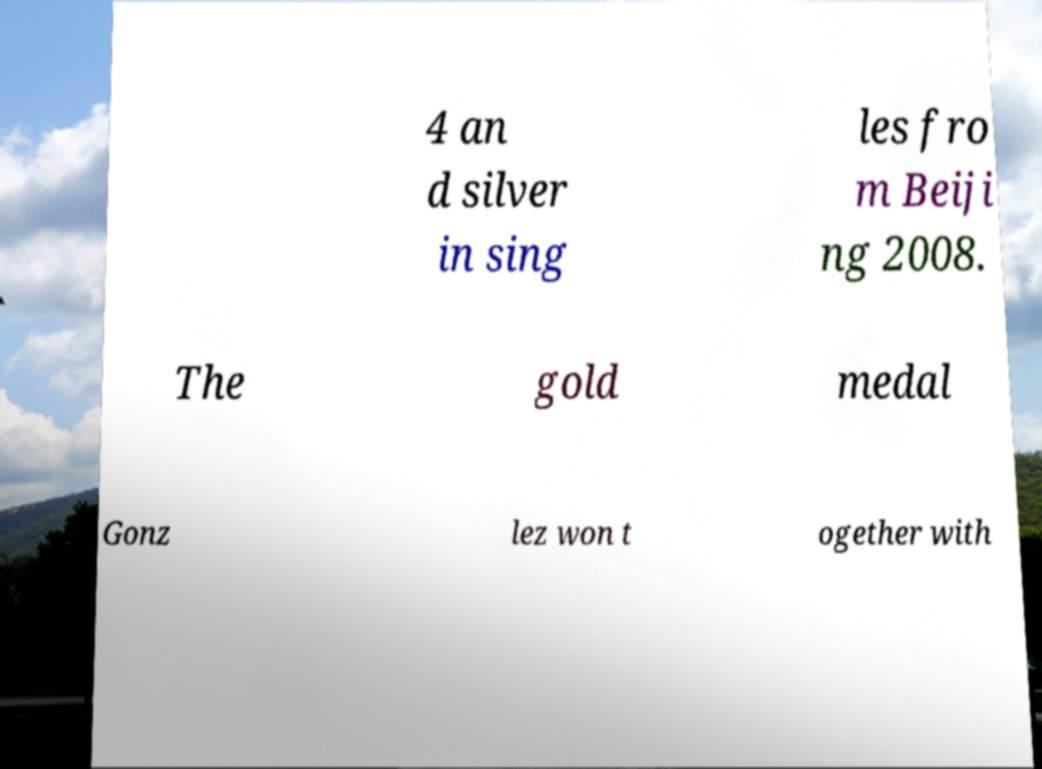Please read and relay the text visible in this image. What does it say? 4 an d silver in sing les fro m Beiji ng 2008. The gold medal Gonz lez won t ogether with 